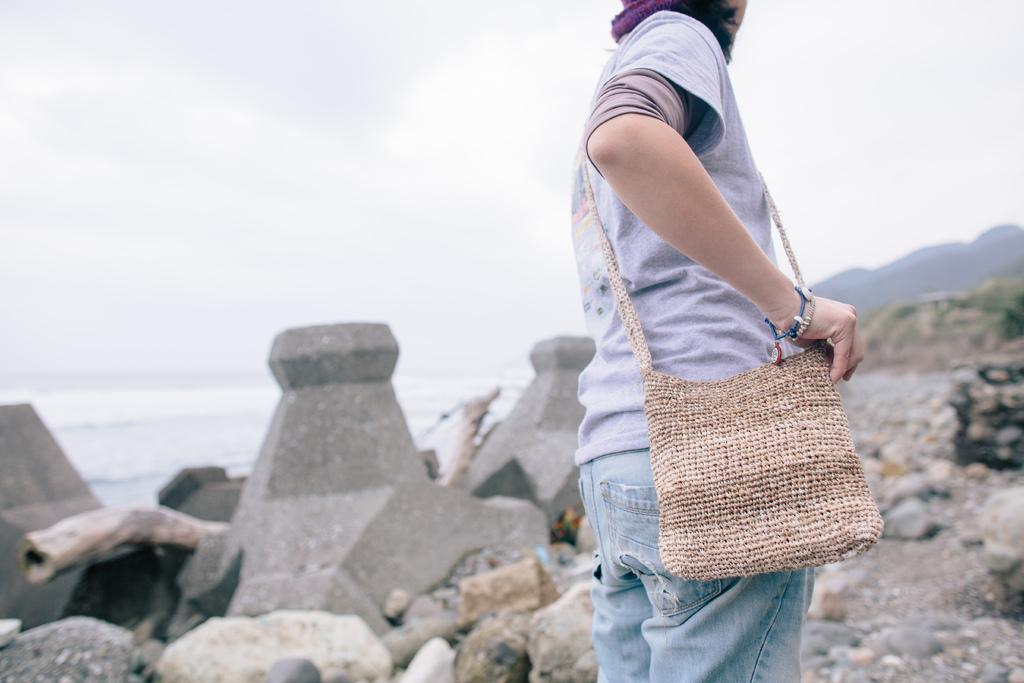What is the main subject of the image? There is a person standing in the image. What is the person wearing? The person is wearing a bag. What type of natural elements can be seen in the image? There are rocks and water visible in the image. What is visible in the background of the image? The sky is visible in the image. What type of ice can be seen melting on the person's head in the image? There is no ice present on the person's head in the image. What kind of medical advice is the doctor giving to the person in the image? There is no doctor present in the image, so no medical advice can be given. 